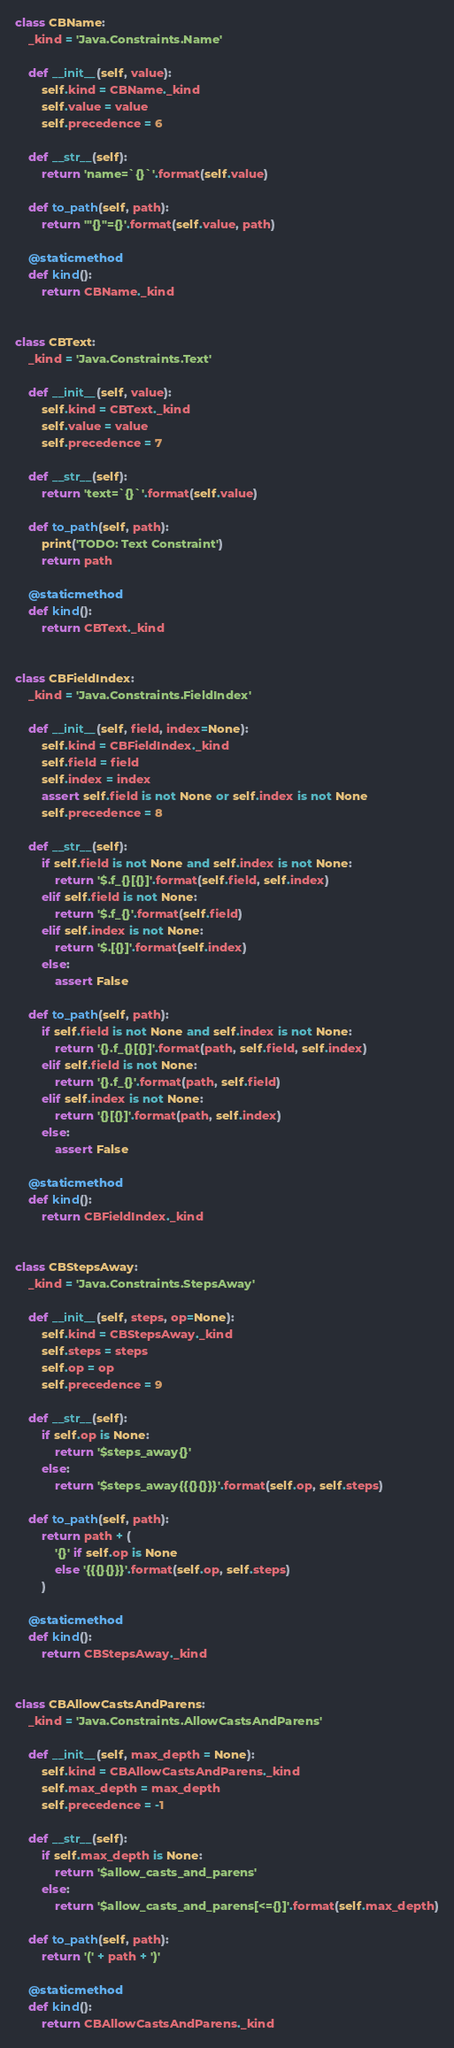<code> <loc_0><loc_0><loc_500><loc_500><_Python_>

class CBName:
    _kind = 'Java.Constraints.Name'

    def __init__(self, value):
        self.kind = CBName._kind
        self.value = value
        self.precedence = 6

    def __str__(self):
        return 'name=`{}`'.format(self.value)

    def to_path(self, path):
        return '"{}"={}'.format(self.value, path)

    @staticmethod
    def kind():
        return CBName._kind


class CBText:
    _kind = 'Java.Constraints.Text'

    def __init__(self, value):
        self.kind = CBText._kind
        self.value = value
        self.precedence = 7

    def __str__(self):
        return 'text=`{}`'.format(self.value)

    def to_path(self, path):
        print('TODO: Text Constraint')
        return path

    @staticmethod
    def kind():
        return CBText._kind


class CBFieldIndex:
    _kind = 'Java.Constraints.FieldIndex'

    def __init__(self, field, index=None):
        self.kind = CBFieldIndex._kind
        self.field = field
        self.index = index
        assert self.field is not None or self.index is not None
        self.precedence = 8

    def __str__(self):
        if self.field is not None and self.index is not None:
            return '$.f_{}[{}]'.format(self.field, self.index)
        elif self.field is not None:
            return '$.f_{}'.format(self.field)
        elif self.index is not None:
            return '$.[{}]'.format(self.index)
        else:
            assert False

    def to_path(self, path):
        if self.field is not None and self.index is not None:
            return '{}.f_{}[{}]'.format(path, self.field, self.index)
        elif self.field is not None:
            return '{}.f_{}'.format(path, self.field)
        elif self.index is not None:
            return '{}[{}]'.format(path, self.index)
        else:
            assert False

    @staticmethod
    def kind():
        return CBFieldIndex._kind


class CBStepsAway:
    _kind = 'Java.Constraints.StepsAway'

    def __init__(self, steps, op=None):
        self.kind = CBStepsAway._kind
        self.steps = steps
        self.op = op
        self.precedence = 9

    def __str__(self):
        if self.op is None:
            return '$steps_away{}'
        else:
            return '$steps_away{{{}{}}}'.format(self.op, self.steps)

    def to_path(self, path):
        return path + (
            '{}' if self.op is None 
            else '{{{}{}}}'.format(self.op, self.steps)
        )

    @staticmethod
    def kind():
        return CBStepsAway._kind


class CBAllowCastsAndParens:
    _kind = 'Java.Constraints.AllowCastsAndParens'

    def __init__(self, max_depth = None):
        self.kind = CBAllowCastsAndParens._kind
        self.max_depth = max_depth
        self.precedence = -1

    def __str__(self):
        if self.max_depth is None:
            return '$allow_casts_and_parens'
        else:
            return '$allow_casts_and_parens[<={}]'.format(self.max_depth)

    def to_path(self, path):
        return '(' + path + ')'

    @staticmethod
    def kind():
        return CBAllowCastsAndParens._kind
</code> 